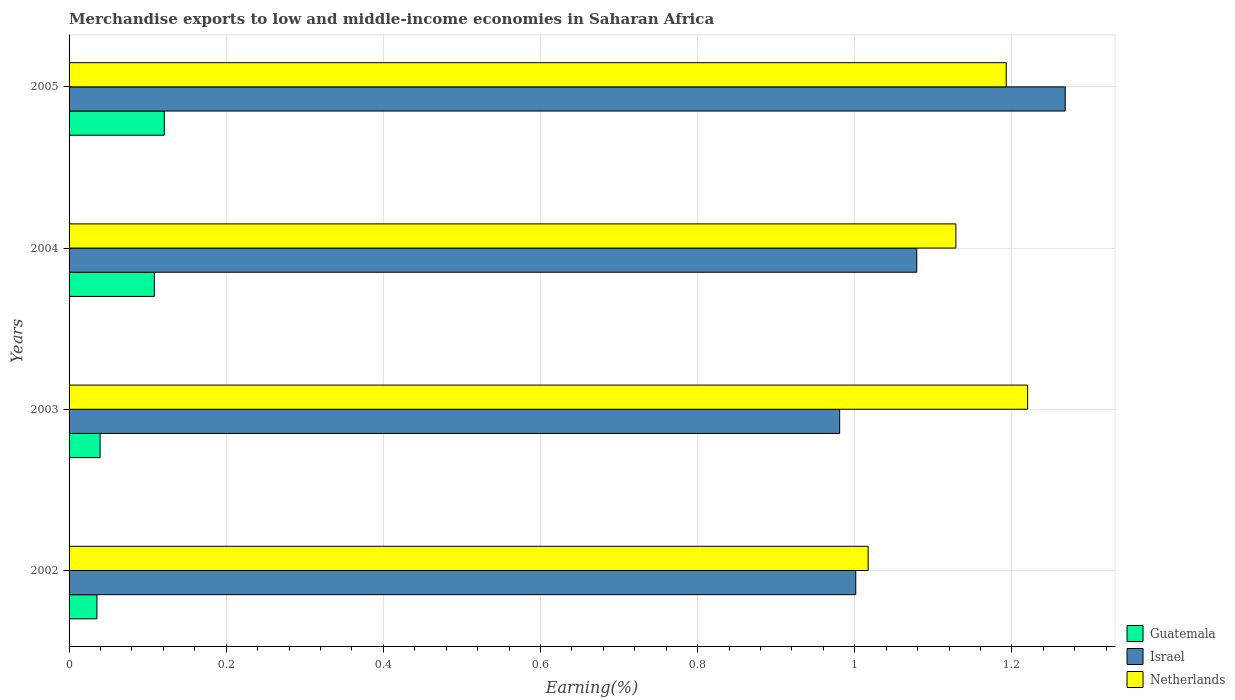How many different coloured bars are there?
Make the answer very short. 3. How many groups of bars are there?
Your response must be concise. 4. How many bars are there on the 3rd tick from the top?
Your answer should be very brief. 3. How many bars are there on the 3rd tick from the bottom?
Offer a very short reply. 3. What is the label of the 4th group of bars from the top?
Your answer should be compact. 2002. In how many cases, is the number of bars for a given year not equal to the number of legend labels?
Offer a terse response. 0. What is the percentage of amount earned from merchandise exports in Guatemala in 2004?
Ensure brevity in your answer.  0.11. Across all years, what is the maximum percentage of amount earned from merchandise exports in Israel?
Provide a short and direct response. 1.27. Across all years, what is the minimum percentage of amount earned from merchandise exports in Netherlands?
Your response must be concise. 1.02. In which year was the percentage of amount earned from merchandise exports in Israel maximum?
Provide a short and direct response. 2005. What is the total percentage of amount earned from merchandise exports in Israel in the graph?
Offer a terse response. 4.33. What is the difference between the percentage of amount earned from merchandise exports in Israel in 2002 and that in 2003?
Your answer should be very brief. 0.02. What is the difference between the percentage of amount earned from merchandise exports in Israel in 2004 and the percentage of amount earned from merchandise exports in Netherlands in 2002?
Give a very brief answer. 0.06. What is the average percentage of amount earned from merchandise exports in Israel per year?
Keep it short and to the point. 1.08. In the year 2002, what is the difference between the percentage of amount earned from merchandise exports in Netherlands and percentage of amount earned from merchandise exports in Israel?
Ensure brevity in your answer.  0.02. In how many years, is the percentage of amount earned from merchandise exports in Israel greater than 0.7600000000000001 %?
Make the answer very short. 4. What is the ratio of the percentage of amount earned from merchandise exports in Guatemala in 2002 to that in 2004?
Make the answer very short. 0.33. Is the percentage of amount earned from merchandise exports in Netherlands in 2002 less than that in 2005?
Your answer should be very brief. Yes. What is the difference between the highest and the second highest percentage of amount earned from merchandise exports in Guatemala?
Make the answer very short. 0.01. What is the difference between the highest and the lowest percentage of amount earned from merchandise exports in Guatemala?
Offer a very short reply. 0.09. What is the difference between two consecutive major ticks on the X-axis?
Offer a terse response. 0.2. Are the values on the major ticks of X-axis written in scientific E-notation?
Provide a succinct answer. No. Where does the legend appear in the graph?
Offer a very short reply. Bottom right. How many legend labels are there?
Your answer should be very brief. 3. What is the title of the graph?
Offer a very short reply. Merchandise exports to low and middle-income economies in Saharan Africa. What is the label or title of the X-axis?
Your response must be concise. Earning(%). What is the Earning(%) in Guatemala in 2002?
Provide a succinct answer. 0.04. What is the Earning(%) in Israel in 2002?
Offer a very short reply. 1. What is the Earning(%) in Netherlands in 2002?
Your answer should be compact. 1.02. What is the Earning(%) in Guatemala in 2003?
Your answer should be very brief. 0.04. What is the Earning(%) in Israel in 2003?
Your answer should be compact. 0.98. What is the Earning(%) of Netherlands in 2003?
Offer a very short reply. 1.22. What is the Earning(%) of Guatemala in 2004?
Provide a short and direct response. 0.11. What is the Earning(%) of Israel in 2004?
Your answer should be compact. 1.08. What is the Earning(%) of Netherlands in 2004?
Provide a short and direct response. 1.13. What is the Earning(%) of Guatemala in 2005?
Provide a succinct answer. 0.12. What is the Earning(%) in Israel in 2005?
Your answer should be very brief. 1.27. What is the Earning(%) of Netherlands in 2005?
Provide a succinct answer. 1.19. Across all years, what is the maximum Earning(%) in Guatemala?
Your response must be concise. 0.12. Across all years, what is the maximum Earning(%) in Israel?
Provide a short and direct response. 1.27. Across all years, what is the maximum Earning(%) in Netherlands?
Give a very brief answer. 1.22. Across all years, what is the minimum Earning(%) in Guatemala?
Offer a terse response. 0.04. Across all years, what is the minimum Earning(%) of Israel?
Provide a succinct answer. 0.98. Across all years, what is the minimum Earning(%) of Netherlands?
Ensure brevity in your answer.  1.02. What is the total Earning(%) in Guatemala in the graph?
Make the answer very short. 0.3. What is the total Earning(%) in Israel in the graph?
Offer a very short reply. 4.33. What is the total Earning(%) in Netherlands in the graph?
Keep it short and to the point. 4.56. What is the difference between the Earning(%) of Guatemala in 2002 and that in 2003?
Your response must be concise. -0. What is the difference between the Earning(%) in Israel in 2002 and that in 2003?
Offer a very short reply. 0.02. What is the difference between the Earning(%) in Netherlands in 2002 and that in 2003?
Provide a short and direct response. -0.2. What is the difference between the Earning(%) in Guatemala in 2002 and that in 2004?
Make the answer very short. -0.07. What is the difference between the Earning(%) in Israel in 2002 and that in 2004?
Offer a very short reply. -0.08. What is the difference between the Earning(%) of Netherlands in 2002 and that in 2004?
Keep it short and to the point. -0.11. What is the difference between the Earning(%) in Guatemala in 2002 and that in 2005?
Offer a very short reply. -0.09. What is the difference between the Earning(%) in Israel in 2002 and that in 2005?
Give a very brief answer. -0.27. What is the difference between the Earning(%) of Netherlands in 2002 and that in 2005?
Ensure brevity in your answer.  -0.18. What is the difference between the Earning(%) of Guatemala in 2003 and that in 2004?
Provide a succinct answer. -0.07. What is the difference between the Earning(%) of Israel in 2003 and that in 2004?
Provide a succinct answer. -0.1. What is the difference between the Earning(%) of Netherlands in 2003 and that in 2004?
Keep it short and to the point. 0.09. What is the difference between the Earning(%) in Guatemala in 2003 and that in 2005?
Offer a very short reply. -0.08. What is the difference between the Earning(%) in Israel in 2003 and that in 2005?
Your answer should be compact. -0.29. What is the difference between the Earning(%) in Netherlands in 2003 and that in 2005?
Offer a terse response. 0.03. What is the difference between the Earning(%) in Guatemala in 2004 and that in 2005?
Ensure brevity in your answer.  -0.01. What is the difference between the Earning(%) in Israel in 2004 and that in 2005?
Offer a very short reply. -0.19. What is the difference between the Earning(%) of Netherlands in 2004 and that in 2005?
Your response must be concise. -0.06. What is the difference between the Earning(%) of Guatemala in 2002 and the Earning(%) of Israel in 2003?
Your response must be concise. -0.95. What is the difference between the Earning(%) in Guatemala in 2002 and the Earning(%) in Netherlands in 2003?
Your answer should be compact. -1.18. What is the difference between the Earning(%) of Israel in 2002 and the Earning(%) of Netherlands in 2003?
Your answer should be very brief. -0.22. What is the difference between the Earning(%) of Guatemala in 2002 and the Earning(%) of Israel in 2004?
Keep it short and to the point. -1.04. What is the difference between the Earning(%) in Guatemala in 2002 and the Earning(%) in Netherlands in 2004?
Offer a terse response. -1.09. What is the difference between the Earning(%) of Israel in 2002 and the Earning(%) of Netherlands in 2004?
Provide a succinct answer. -0.13. What is the difference between the Earning(%) in Guatemala in 2002 and the Earning(%) in Israel in 2005?
Keep it short and to the point. -1.23. What is the difference between the Earning(%) in Guatemala in 2002 and the Earning(%) in Netherlands in 2005?
Your answer should be very brief. -1.16. What is the difference between the Earning(%) of Israel in 2002 and the Earning(%) of Netherlands in 2005?
Your answer should be very brief. -0.19. What is the difference between the Earning(%) of Guatemala in 2003 and the Earning(%) of Israel in 2004?
Keep it short and to the point. -1.04. What is the difference between the Earning(%) of Guatemala in 2003 and the Earning(%) of Netherlands in 2004?
Make the answer very short. -1.09. What is the difference between the Earning(%) of Israel in 2003 and the Earning(%) of Netherlands in 2004?
Offer a terse response. -0.15. What is the difference between the Earning(%) in Guatemala in 2003 and the Earning(%) in Israel in 2005?
Offer a terse response. -1.23. What is the difference between the Earning(%) in Guatemala in 2003 and the Earning(%) in Netherlands in 2005?
Offer a very short reply. -1.15. What is the difference between the Earning(%) in Israel in 2003 and the Earning(%) in Netherlands in 2005?
Keep it short and to the point. -0.21. What is the difference between the Earning(%) in Guatemala in 2004 and the Earning(%) in Israel in 2005?
Give a very brief answer. -1.16. What is the difference between the Earning(%) in Guatemala in 2004 and the Earning(%) in Netherlands in 2005?
Offer a very short reply. -1.08. What is the difference between the Earning(%) in Israel in 2004 and the Earning(%) in Netherlands in 2005?
Give a very brief answer. -0.11. What is the average Earning(%) in Guatemala per year?
Offer a terse response. 0.08. What is the average Earning(%) in Israel per year?
Your answer should be very brief. 1.08. What is the average Earning(%) of Netherlands per year?
Provide a short and direct response. 1.14. In the year 2002, what is the difference between the Earning(%) in Guatemala and Earning(%) in Israel?
Keep it short and to the point. -0.97. In the year 2002, what is the difference between the Earning(%) in Guatemala and Earning(%) in Netherlands?
Provide a short and direct response. -0.98. In the year 2002, what is the difference between the Earning(%) of Israel and Earning(%) of Netherlands?
Provide a succinct answer. -0.02. In the year 2003, what is the difference between the Earning(%) of Guatemala and Earning(%) of Israel?
Ensure brevity in your answer.  -0.94. In the year 2003, what is the difference between the Earning(%) of Guatemala and Earning(%) of Netherlands?
Offer a very short reply. -1.18. In the year 2003, what is the difference between the Earning(%) of Israel and Earning(%) of Netherlands?
Offer a very short reply. -0.24. In the year 2004, what is the difference between the Earning(%) in Guatemala and Earning(%) in Israel?
Give a very brief answer. -0.97. In the year 2004, what is the difference between the Earning(%) in Guatemala and Earning(%) in Netherlands?
Offer a very short reply. -1.02. In the year 2004, what is the difference between the Earning(%) in Israel and Earning(%) in Netherlands?
Keep it short and to the point. -0.05. In the year 2005, what is the difference between the Earning(%) in Guatemala and Earning(%) in Israel?
Make the answer very short. -1.15. In the year 2005, what is the difference between the Earning(%) of Guatemala and Earning(%) of Netherlands?
Your answer should be compact. -1.07. In the year 2005, what is the difference between the Earning(%) in Israel and Earning(%) in Netherlands?
Your answer should be very brief. 0.08. What is the ratio of the Earning(%) in Guatemala in 2002 to that in 2003?
Offer a very short reply. 0.9. What is the ratio of the Earning(%) in Israel in 2002 to that in 2003?
Make the answer very short. 1.02. What is the ratio of the Earning(%) of Netherlands in 2002 to that in 2003?
Offer a terse response. 0.83. What is the ratio of the Earning(%) in Guatemala in 2002 to that in 2004?
Ensure brevity in your answer.  0.33. What is the ratio of the Earning(%) of Israel in 2002 to that in 2004?
Give a very brief answer. 0.93. What is the ratio of the Earning(%) of Netherlands in 2002 to that in 2004?
Your answer should be compact. 0.9. What is the ratio of the Earning(%) of Guatemala in 2002 to that in 2005?
Your response must be concise. 0.29. What is the ratio of the Earning(%) of Israel in 2002 to that in 2005?
Make the answer very short. 0.79. What is the ratio of the Earning(%) of Netherlands in 2002 to that in 2005?
Provide a short and direct response. 0.85. What is the ratio of the Earning(%) in Guatemala in 2003 to that in 2004?
Offer a terse response. 0.36. What is the ratio of the Earning(%) of Israel in 2003 to that in 2004?
Give a very brief answer. 0.91. What is the ratio of the Earning(%) in Netherlands in 2003 to that in 2004?
Offer a terse response. 1.08. What is the ratio of the Earning(%) in Guatemala in 2003 to that in 2005?
Offer a terse response. 0.33. What is the ratio of the Earning(%) of Israel in 2003 to that in 2005?
Your answer should be compact. 0.77. What is the ratio of the Earning(%) in Netherlands in 2003 to that in 2005?
Offer a very short reply. 1.02. What is the ratio of the Earning(%) of Guatemala in 2004 to that in 2005?
Your answer should be very brief. 0.9. What is the ratio of the Earning(%) of Israel in 2004 to that in 2005?
Keep it short and to the point. 0.85. What is the ratio of the Earning(%) in Netherlands in 2004 to that in 2005?
Give a very brief answer. 0.95. What is the difference between the highest and the second highest Earning(%) in Guatemala?
Your answer should be compact. 0.01. What is the difference between the highest and the second highest Earning(%) of Israel?
Provide a short and direct response. 0.19. What is the difference between the highest and the second highest Earning(%) in Netherlands?
Keep it short and to the point. 0.03. What is the difference between the highest and the lowest Earning(%) of Guatemala?
Provide a succinct answer. 0.09. What is the difference between the highest and the lowest Earning(%) of Israel?
Make the answer very short. 0.29. What is the difference between the highest and the lowest Earning(%) in Netherlands?
Provide a succinct answer. 0.2. 